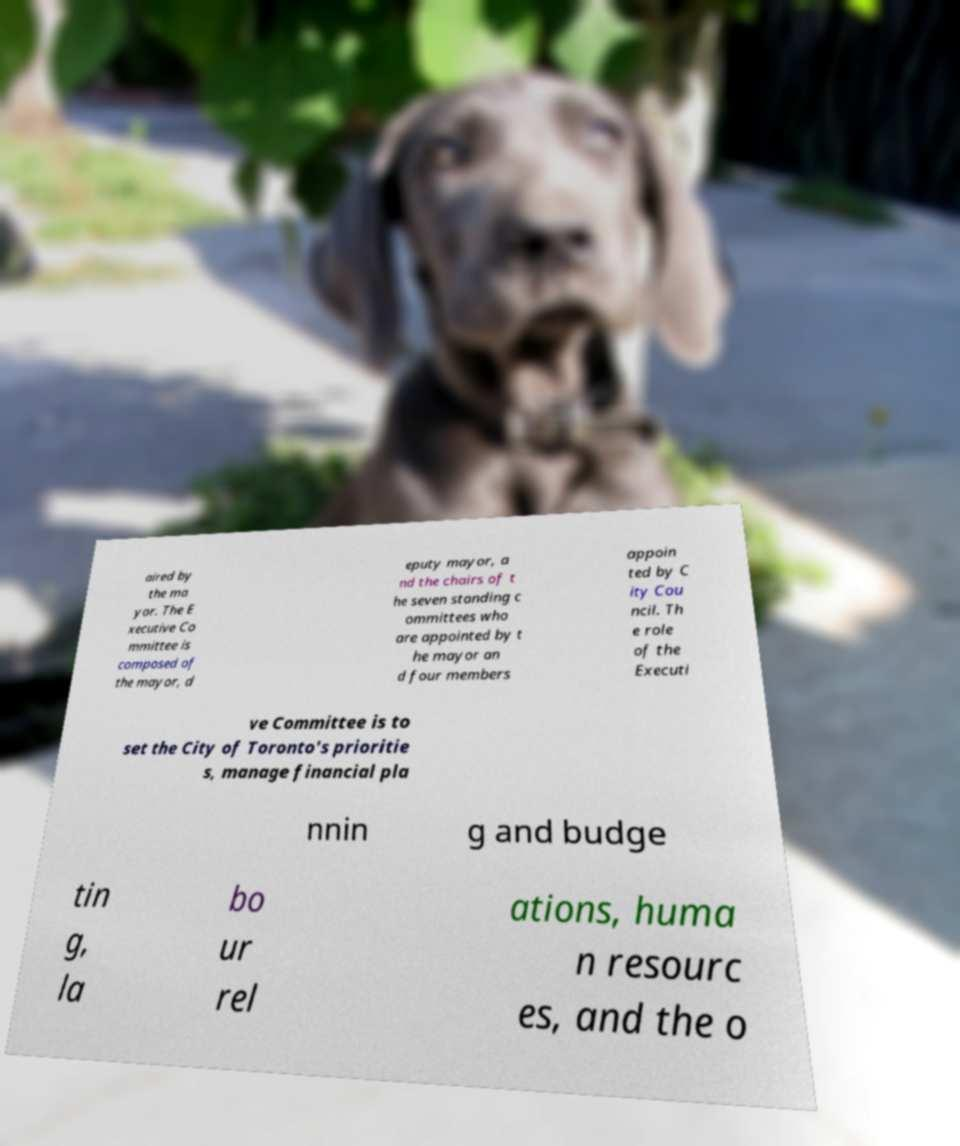Can you read and provide the text displayed in the image?This photo seems to have some interesting text. Can you extract and type it out for me? aired by the ma yor. The E xecutive Co mmittee is composed of the mayor, d eputy mayor, a nd the chairs of t he seven standing c ommittees who are appointed by t he mayor an d four members appoin ted by C ity Cou ncil. Th e role of the Executi ve Committee is to set the City of Toronto's prioritie s, manage financial pla nnin g and budge tin g, la bo ur rel ations, huma n resourc es, and the o 